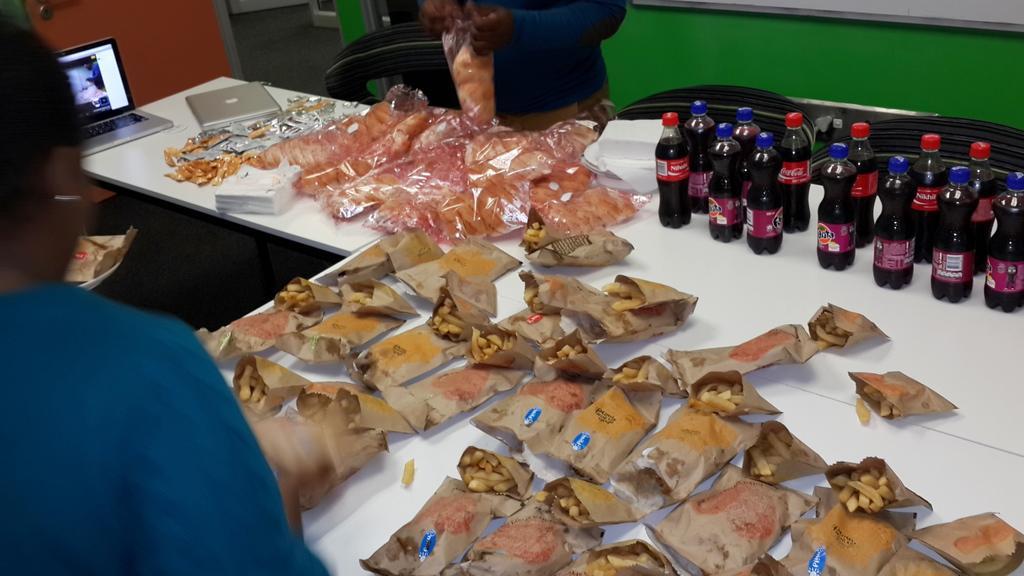How would you summarize this image in a sentence or two? On this white table we can see laptops, soft drink bottles, plates, tissue papers and food packets with food. This man is holding a food packet.  